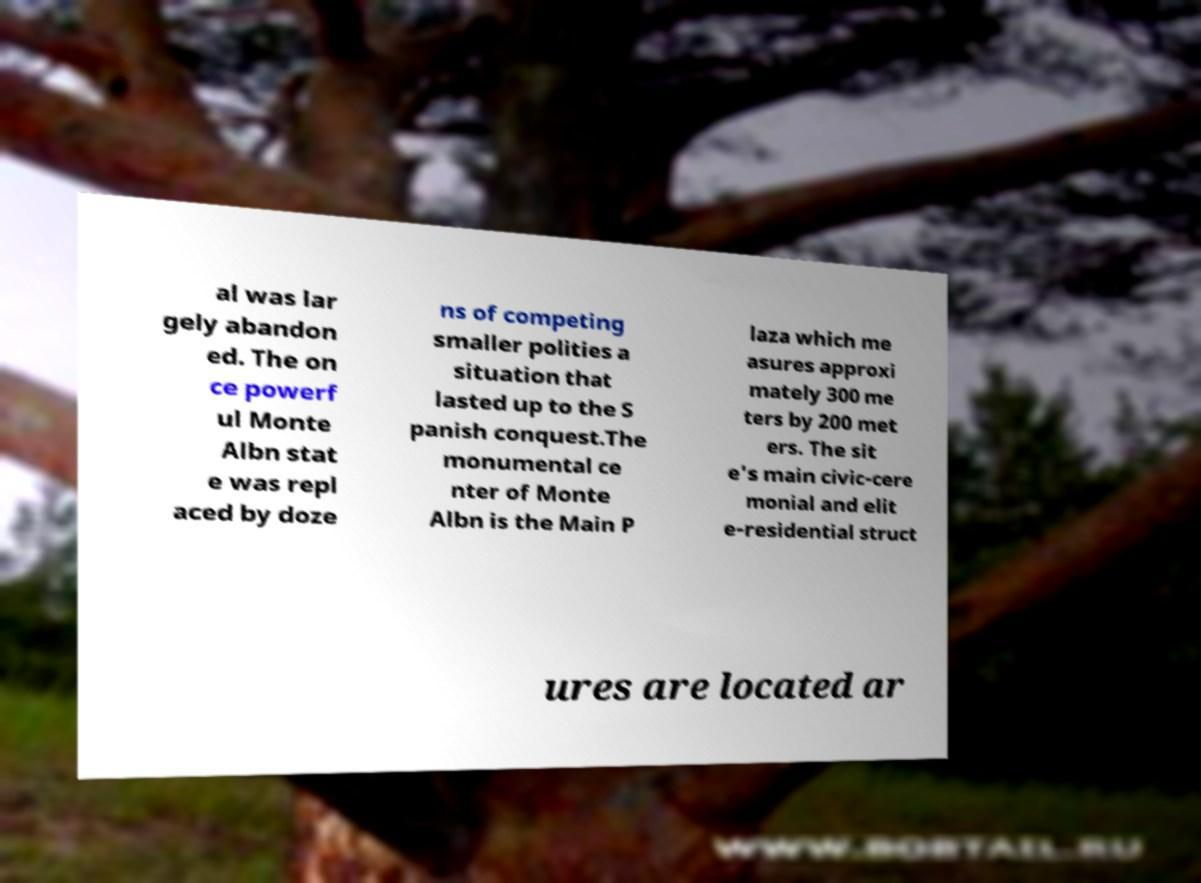What messages or text are displayed in this image? I need them in a readable, typed format. al was lar gely abandon ed. The on ce powerf ul Monte Albn stat e was repl aced by doze ns of competing smaller polities a situation that lasted up to the S panish conquest.The monumental ce nter of Monte Albn is the Main P laza which me asures approxi mately 300 me ters by 200 met ers. The sit e's main civic-cere monial and elit e-residential struct ures are located ar 